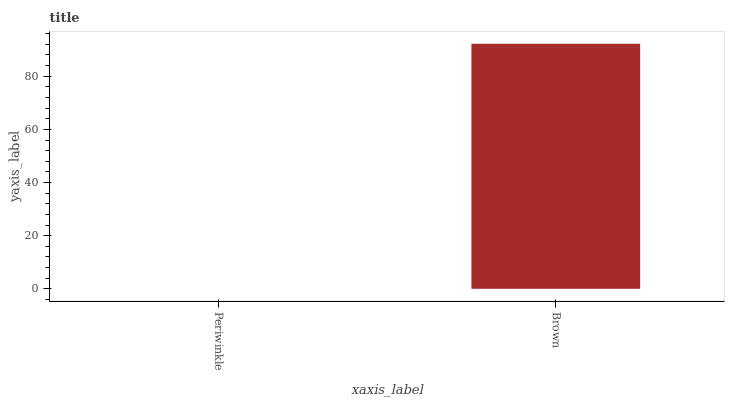Is Periwinkle the minimum?
Answer yes or no. Yes. Is Brown the maximum?
Answer yes or no. Yes. Is Brown the minimum?
Answer yes or no. No. Is Brown greater than Periwinkle?
Answer yes or no. Yes. Is Periwinkle less than Brown?
Answer yes or no. Yes. Is Periwinkle greater than Brown?
Answer yes or no. No. Is Brown less than Periwinkle?
Answer yes or no. No. Is Brown the high median?
Answer yes or no. Yes. Is Periwinkle the low median?
Answer yes or no. Yes. Is Periwinkle the high median?
Answer yes or no. No. Is Brown the low median?
Answer yes or no. No. 